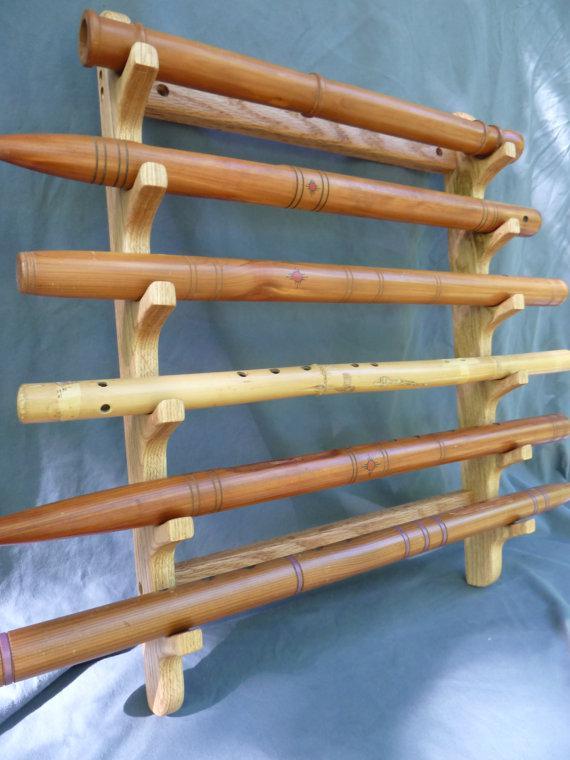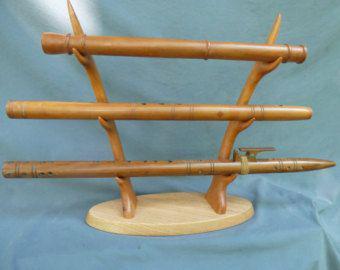The first image is the image on the left, the second image is the image on the right. Analyze the images presented: Is the assertion "In the image to the right, three parts of a flute are held horizontally." valid? Answer yes or no. Yes. The first image is the image on the left, the second image is the image on the right. For the images displayed, is the sentence "In the right image, the instruments are displayed horizontally." factually correct? Answer yes or no. Yes. 